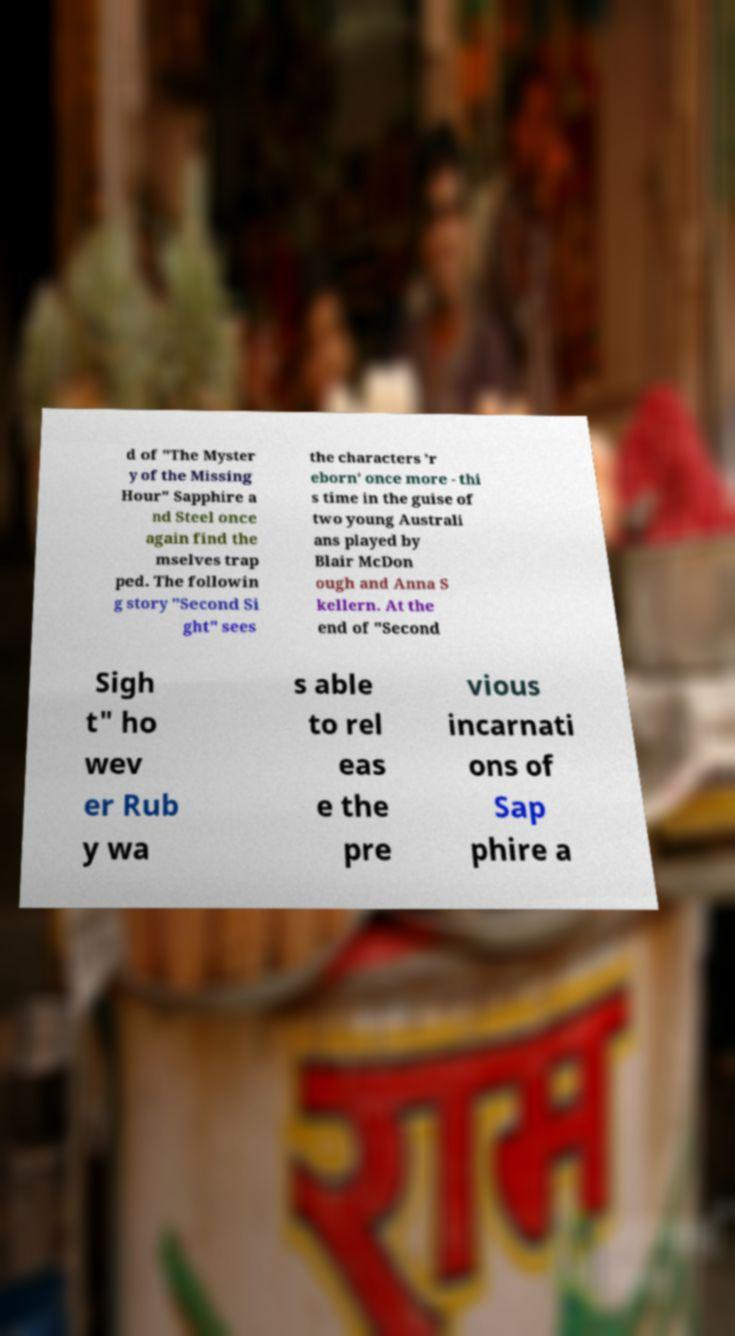Please read and relay the text visible in this image. What does it say? d of "The Myster y of the Missing Hour" Sapphire a nd Steel once again find the mselves trap ped. The followin g story "Second Si ght" sees the characters 'r eborn' once more - thi s time in the guise of two young Australi ans played by Blair McDon ough and Anna S kellern. At the end of "Second Sigh t" ho wev er Rub y wa s able to rel eas e the pre vious incarnati ons of Sap phire a 